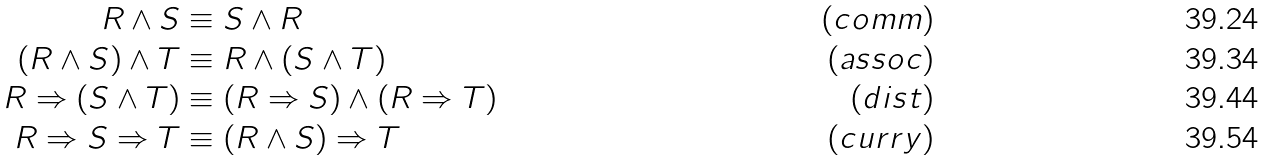Convert formula to latex. <formula><loc_0><loc_0><loc_500><loc_500>R \wedge S & \equiv S \wedge R & ( c o m m ) \\ ( R \wedge S ) \wedge T & \equiv R \wedge ( S \wedge T ) & ( a s s o c ) \\ R \Rightarrow ( S \wedge T ) & \equiv ( R \Rightarrow S ) \wedge ( R \Rightarrow T ) & ( d i s t ) \\ R \Rightarrow S \Rightarrow T & \equiv ( R \wedge S ) \Rightarrow T & ( c u r r y )</formula> 